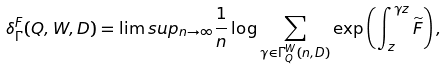Convert formula to latex. <formula><loc_0><loc_0><loc_500><loc_500>\delta ^ { F } _ { \Gamma } ( Q , W , D ) = \lim s u p _ { n \to \infty } \frac { 1 } { n } \log \sum _ { \gamma \in \Gamma ^ { W } _ { Q } ( n , D ) } \exp \left ( \int _ { z } ^ { \gamma z } \widetilde { F } \right ) ,</formula> 